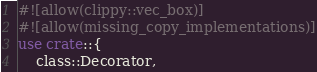<code> <loc_0><loc_0><loc_500><loc_500><_Rust_>#![allow(clippy::vec_box)]
#![allow(missing_copy_implementations)]
use crate::{
    class::Decorator,</code> 